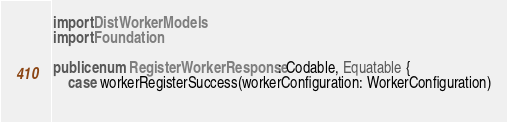Convert code to text. <code><loc_0><loc_0><loc_500><loc_500><_Swift_>import DistWorkerModels
import Foundation

public enum RegisterWorkerResponse: Codable, Equatable {
    case workerRegisterSuccess(workerConfiguration: WorkerConfiguration)
    </code> 